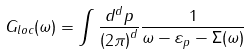Convert formula to latex. <formula><loc_0><loc_0><loc_500><loc_500>G _ { l o c } ( \omega ) = \int \frac { d ^ { d } p } { \left ( 2 \pi \right ) ^ { d } } \frac { 1 } { \omega - \varepsilon _ { p } - \Sigma ( \omega ) }</formula> 